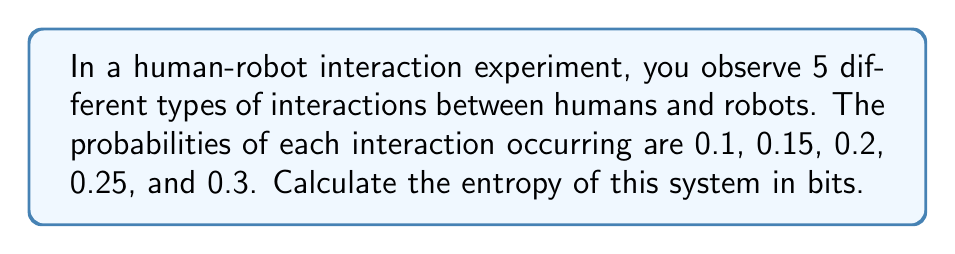Give your solution to this math problem. To calculate the entropy of the system, we'll use the Shannon entropy formula:

$$ S = -\sum_{i=1}^{n} p_i \log_2(p_i) $$

Where:
- $S$ is the entropy
- $p_i$ is the probability of each interaction type
- $n$ is the number of different interaction types

Let's calculate for each interaction type:

1. $p_1 = 0.1$:
   $-0.1 \log_2(0.1) = 0.332$

2. $p_2 = 0.15$:
   $-0.15 \log_2(0.15) = 0.411$

3. $p_3 = 0.2$:
   $-0.2 \log_2(0.2) = 0.464$

4. $p_4 = 0.25$:
   $-0.25 \log_2(0.25) = 0.5$

5. $p_5 = 0.3$:
   $-0.3 \log_2(0.3) = 0.521$

Now, sum all these values:

$$ S = 0.332 + 0.411 + 0.464 + 0.5 + 0.521 = 2.228 $$

Therefore, the entropy of the system is approximately 2.228 bits.
Answer: 2.228 bits 